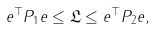<formula> <loc_0><loc_0><loc_500><loc_500>e ^ { \top } P _ { 1 } e \leq \mathfrak { L } \leq e ^ { \top } P _ { 2 } e ,</formula> 